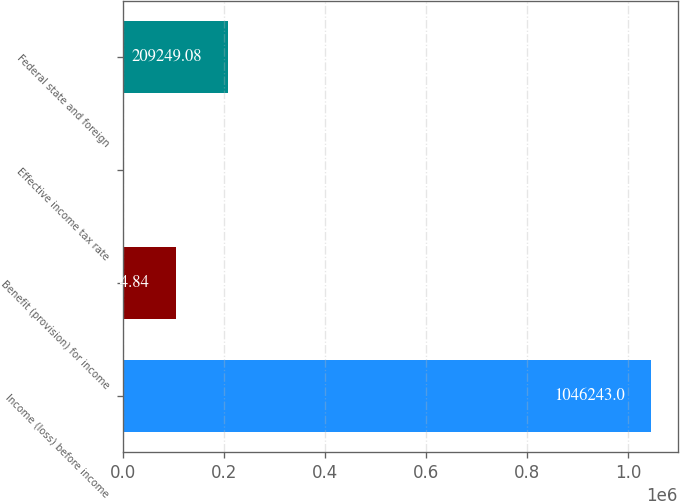<chart> <loc_0><loc_0><loc_500><loc_500><bar_chart><fcel>Income (loss) before income<fcel>Benefit (provision) for income<fcel>Effective income tax rate<fcel>Federal state and foreign<nl><fcel>1.04624e+06<fcel>104625<fcel>0.6<fcel>209249<nl></chart> 